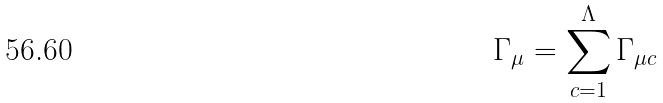Convert formula to latex. <formula><loc_0><loc_0><loc_500><loc_500>\Gamma _ { \mu } = \sum _ { c = 1 } ^ { \Lambda } \Gamma _ { \mu c }</formula> 